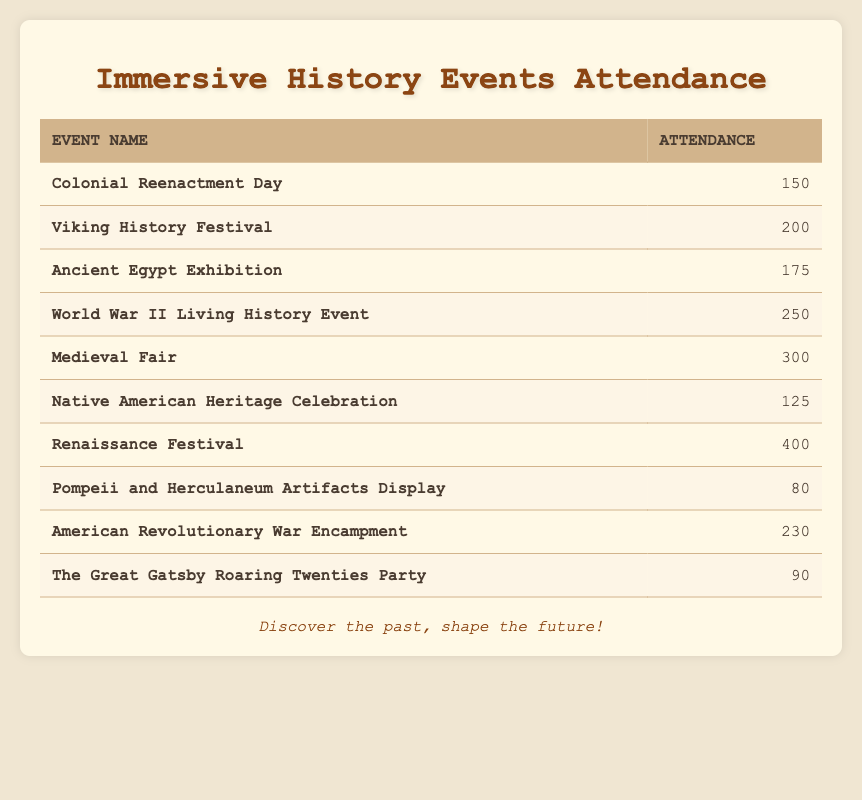What is the total attendance for the Medieval Fair? The table indicates that the attendance for the Medieval Fair is listed as 300. Therefore, the total attendance for this event is directly taken from the table.
Answer: 300 Which event had the highest attendance? By reviewing the attendance values in the table, it shows that the Renaissance Festival has the highest attendance count at 400. Thus, this event ranks as the one with the most participants.
Answer: Renaissance Festival What is the average attendance across all events? First, I sum the attendance numbers: (150 + 200 + 175 + 250 + 300 + 125 + 400 + 80 + 230 + 90) = 2000. There are 10 events, so I divide the total attendance by the number of events: 2000 / 10 = 200. Therefore, the average attendance is calculated to be 200.
Answer: 200 Is the attendance for the Native American Heritage Celebration greater than or equal to 125? The table lists the attendance for the Native American Heritage Celebration as 125. Since the question asks if it is greater than or equal to this number, the answer is yes, because it matches exactly.
Answer: Yes How many events had an attendance of over 200 people? From the table, I identify the events with over 200 people: Viking History Festival (200), World War II Living History Event (250), Medieval Fair (300), Renaissance Festival (400), and American Revolutionary War Encampment (230). This gives me a total of 5 events with attendance exceeding 200.
Answer: 5 What is the difference in attendance between the most and least attended events? The table shows the attendance for the Renaissance Festival (most attended) is 400 and for the Pompeii and Herculaneum Artifacts Display (least attended) is 80. The difference is calculated by subtracting the two values: 400 - 80 = 320. This means there is a difference of 320 attendees between these two events.
Answer: 320 Did more people attend the World War II Living History Event than the Ancient Egypt Exhibition? The table shows the attendance for the World War II Living History Event is 250, while the Ancient Egypt Exhibition's attendance is 175. Since 250 is greater than 175, the answer is yes.
Answer: Yes What is the sum of attendees of the Colonial Reenactment Day and The Great Gatsby Roaring Twenties Party? According to the table, Colonial Reenactment Day has 150 attendees and The Great Gatsby Roaring Twenties Party has 90 attendees. Adding these together gives: 150 + 90 = 240 attendees in total for both events.
Answer: 240 How many events had fewer than 100 attendees? Looking at the table, only the Pompeii and Herculaneum Artifacts Display has an attendance of 80, which is the only event listed that has fewer than 100 attendees. Therefore, the total count is 1.
Answer: 1 